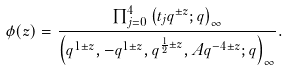<formula> <loc_0><loc_0><loc_500><loc_500>\phi ( z ) = \frac { \prod _ { j = 0 } ^ { 4 } \left ( t _ { j } q ^ { \pm z } ; q \right ) _ { \infty } } { \left ( q ^ { 1 \pm z } , - q ^ { 1 \pm z } , q ^ { \frac { 1 } { 2 } \pm z } , A q ^ { - 4 \pm z } ; q \right ) _ { \infty } } .</formula> 